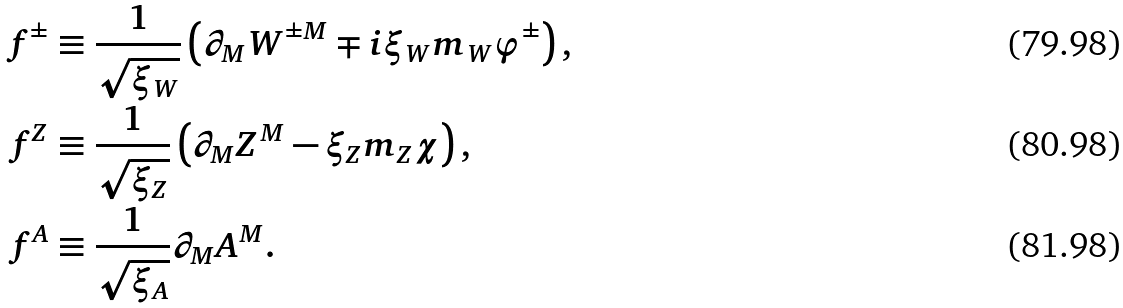<formula> <loc_0><loc_0><loc_500><loc_500>f ^ { \pm } & \equiv \frac { 1 } { \sqrt { \xi _ { W } } } \left ( \partial _ { M } W ^ { \pm M } \mp i \xi _ { W } m _ { W } \varphi ^ { \pm } \right ) , \\ f ^ { Z } & \equiv \frac { 1 } { \sqrt { \xi _ { Z } } } \left ( \partial _ { M } Z ^ { M } - \xi _ { Z } m _ { Z } \chi \right ) , \\ f ^ { A } & \equiv \frac { 1 } { \sqrt { \xi _ { A } } } \partial _ { M } A ^ { M } .</formula> 